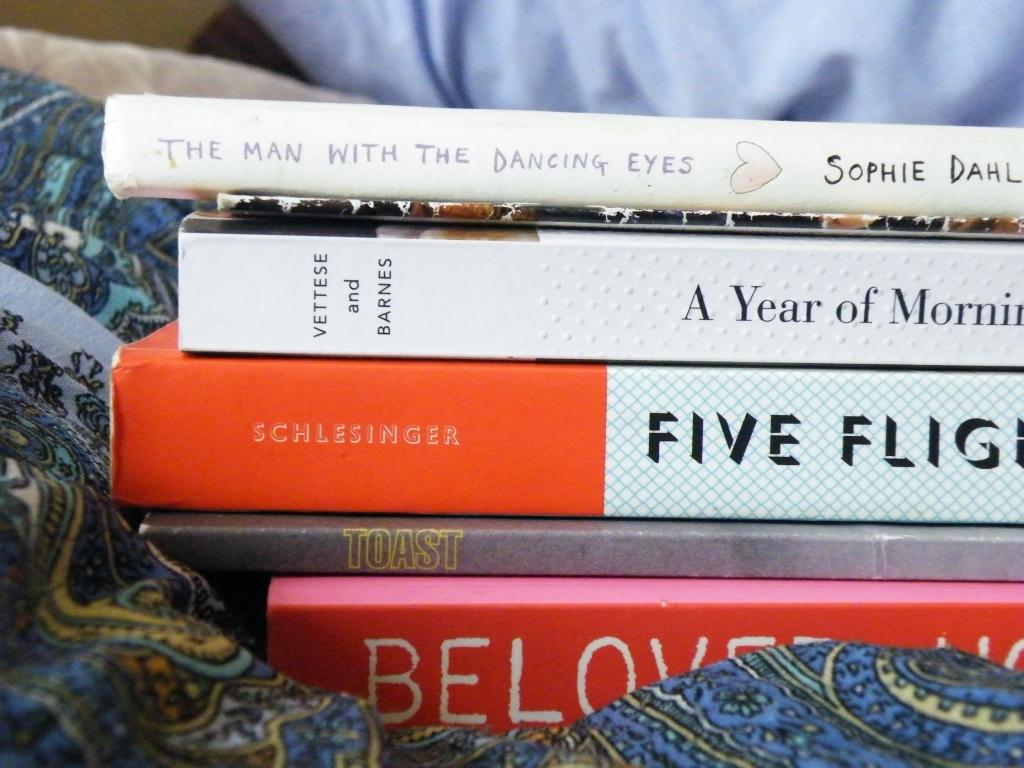What are the book titles?
Offer a terse response. Unanswerable. 